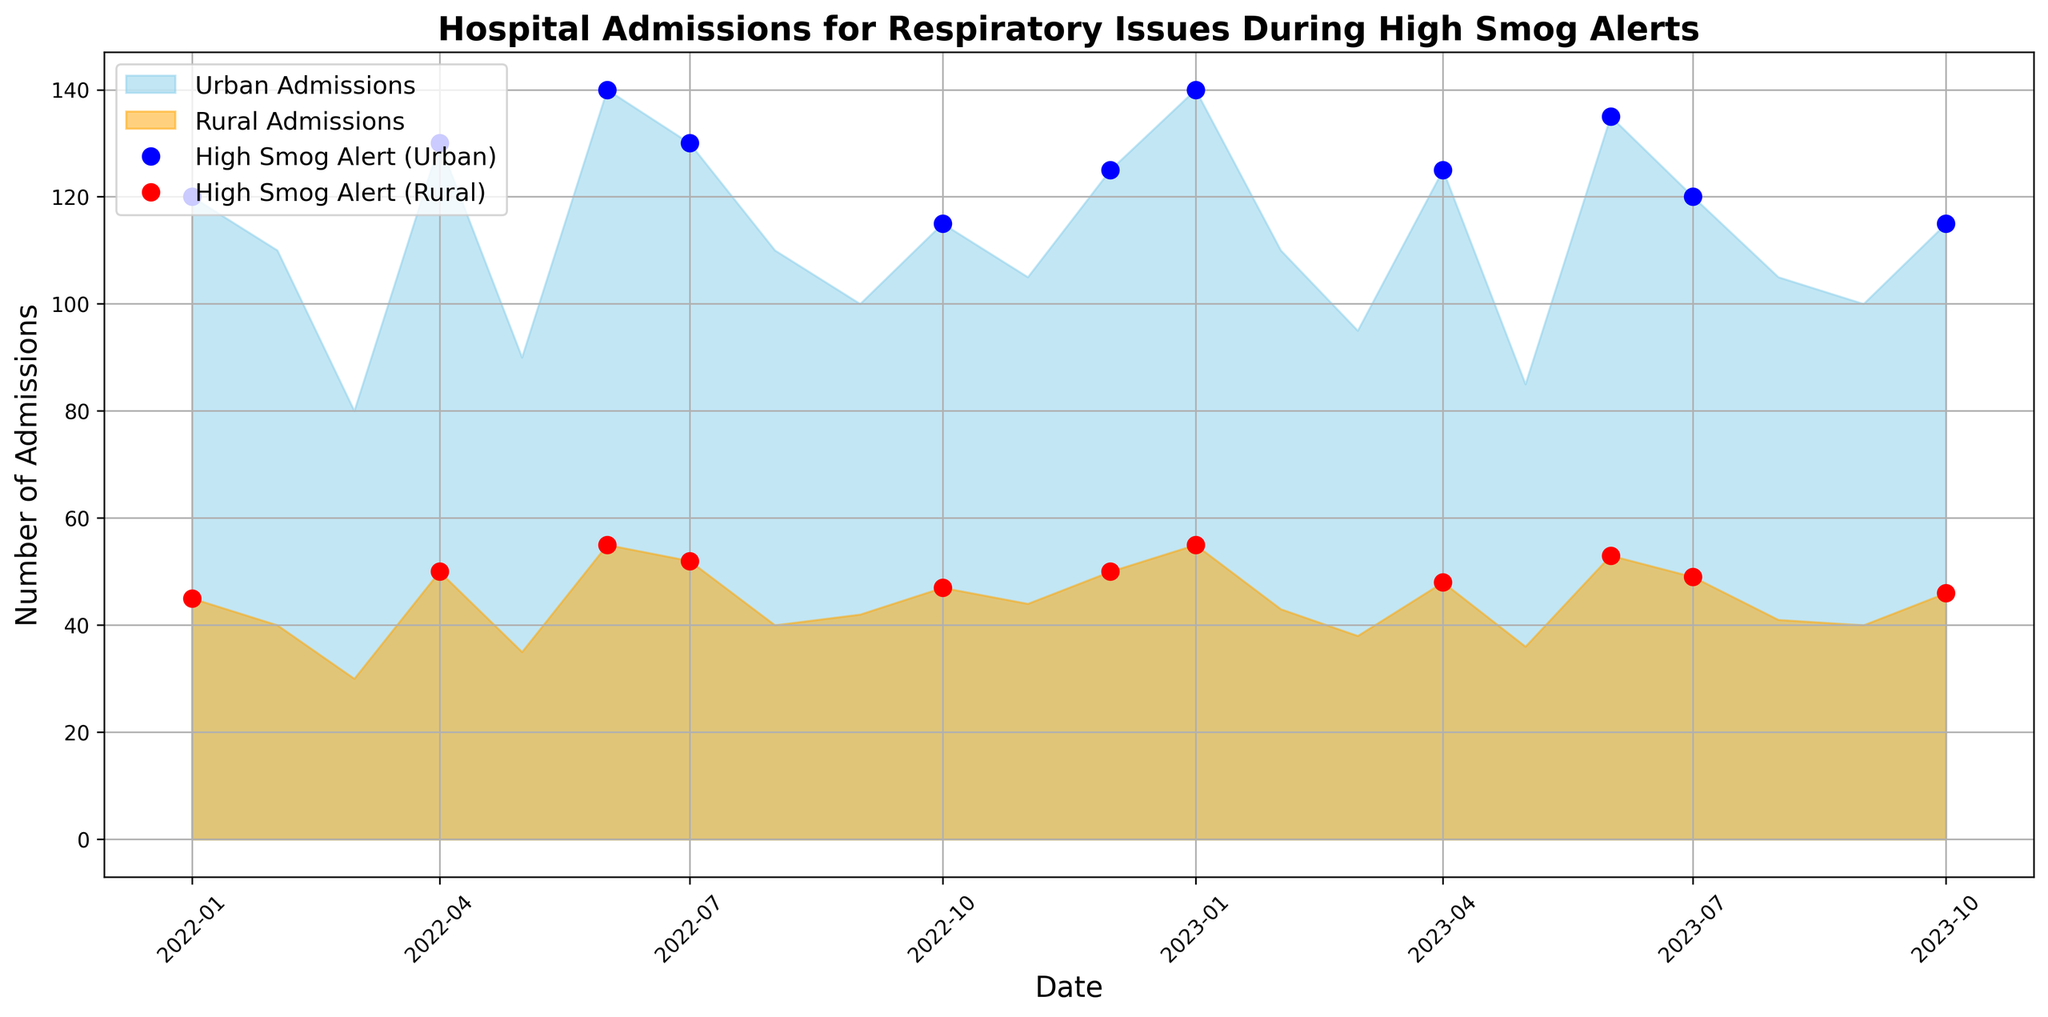What dates have high smog alerts? We can identify high smog alerts by looking for dates marked with blue and red markers. These markers denote high smog alert periods for both urban and rural areas respectively.
Answer: 2022-01-01, 2022-04-01, 2022-06-01, 2022-07-01, 2022-10-01, 2022-12-01, 2023-01-01, 2023-04-01, 2023-06-01, 2023-07-01, 2023-10-01 How do urban and rural admissions compare on the date with the highest smog alert admissions? We find the date with the highest urban or rural admissions among the dates marked with markers. For urban, the highest is 2023-01-01 with 140 admissions. For rural, the same date has 55 admissions.
Answer: Urban: 140, Rural: 55 What is the average number of admissions for urban areas during high smog alerts? First, add the admissions for high smog alert dates: 120+130+140+130+115+125+140+125+135+120+115 = 1395. There are 11 such dates, so the average is 1395 / 11.
Answer: ~127 How much higher are urban admissions compared to rural on 2022-06-01? Urban admissions are 140 and rural admissions are 55 on 2022-06-01. Subtract rural from urban: 140 - 55.
Answer: 85 Which month had the smallest difference between urban and rural admissions? Calculate the difference for each month: January (75), February (70), March (50), April (80), May (55), June (85), July (78), August (70), September (58), October (68), November (61), December (75). The smallest difference is March with a difference of 50.
Answer: March 2022 What is the total number of admissions in rural areas during the first half of 2023? Sum admissions from January to June of 2023: 55+43+38+48+36+53.
Answer: 273 Which high smog alert month had the least urban admissions? Identify urbam admissions in high smog alert months: 2022-01-01 (120), 2022-04-01 (130), 2022-06-01 (140), 2022-07-01 (130), 2022-10-01 (115), 2022-12-01 (125), 2023-01-01 (140), 2023-04-01 (125), 2023-06-01 (135), 2023-07-01 (120), 2023-10-01 (115). The lowest admission is in October 2022 and October 2023 with 115 admissions each.
Answer: October 2022, October 2023 On which date were both urban and rural admissions the most similar? Calculate the difference between urban and rural admissions for each date and identify the smallest difference: 2022-03-01 with difference of (80-30)=50.
Answer: 2022-03-01 How did rural admissions change from January 2022 to January 2023? Rural admissions in January 2022 were 45 and in January 2023 were 55. Calculate the difference: 55 - 45.
Answer: Increased by 10 Which month shows a consistent pattern in admissions for both urban and rural areas? Identify months with similar trends in urban and rural admissions: For example, February over the two years shows declining admissions in both regions (urban: 110, 110 and rural: 40, 43).
Answer: February 